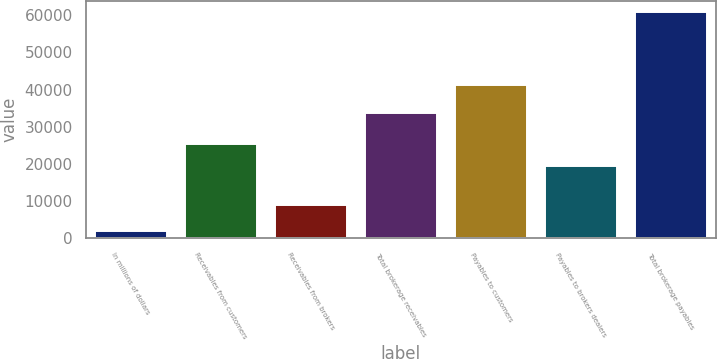<chart> <loc_0><loc_0><loc_500><loc_500><bar_chart><fcel>In millions of dollars<fcel>Receivables from customers<fcel>Receivables from brokers<fcel>Total brokerage receivables<fcel>Payables to customers<fcel>Payables to brokers dealers<fcel>Total brokerage payables<nl><fcel>2009<fcel>25467.7<fcel>8913<fcel>33634<fcel>41262<fcel>19584<fcel>60846<nl></chart> 